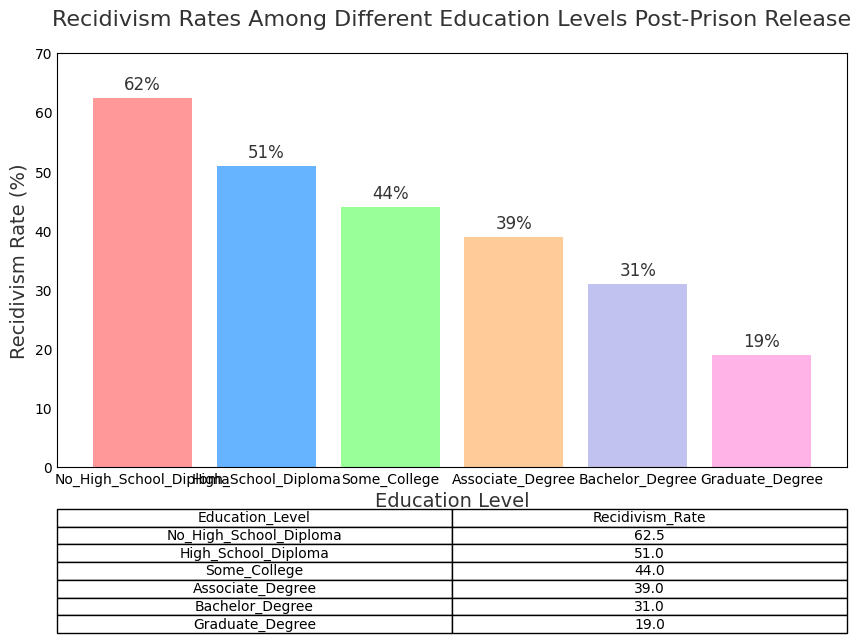What is the recidivism rate for individuals with a Bachelor’s Degree? The figure annotates the height of each bar. For a Bachelor’s Degree, the bar’s height is annotated as 31%
Answer: 31% What education level has the highest recidivism rate? The highest bar represents the "No High School Diploma" category, which is annotated with the highest value of 62.5%
Answer: No High School Diploma By how much does the recidivism rate of those with a Graduate Degree differ from those with an Associate Degree? The annotated values are 19% for Graduate Degree and 39% for Associate Degree. The difference is 39% - 19% = 20%
Answer: 20% What is the average recidivism rate of individuals with at least some college education (Some College, Associate Degree, Bachelor Degree, Graduate Degree)? The values are 44%, 39%, 31%, and 19%. Calculate the mean: (44 + 39 + 31 + 19) / 4 = 133 / 4 = 33.25%
Answer: 33.25% Which education level shows an exactly 10% decrease in recidivism rate compared to those with only a High School Diploma? The High School Diploma rate is 51%. An exactly 10% decrease would put the rate at 41%. The "Some College" category is annotated with 44%, which is closest to this
Answer: Some College How much lower is the recidivism rate with a Graduate Degree compared to a High School Diploma? The Graduate Degree rate is 19%, while the High School Diploma rate is 51%. The difference is 51% - 19% = 32%
Answer: 32% Which education levels have a recidivism rate lower than 50%? By observing the annotated values, Some College (44%), Associate Degree (39%), Bachelor Degree (31%), and Graduate Degree (19%) are all lower than 50%
Answer: Some College, Associate Degree, Bachelor Degree, Graduate Degree Which bar is the shortest in the chart? The shortest bar visually corresponds to the Graduate Degree category with an annotated value of 19%
Answer: Graduate Degree Is the recidivism rate for High School Diploma higher than for Associate Degree? The High School Diploma rate is 51%, and the Associate Degree rate is 39%. 51% is higher than 39%
Answer: Yes What is the difference in recidivism rates between the highest and lowest education levels? The highest rate is for No High School Diploma at 62.5%, and the lowest is for Graduate Degree at 19%. The difference is 62.5% - 19% = 43.5%
Answer: 43.5% 